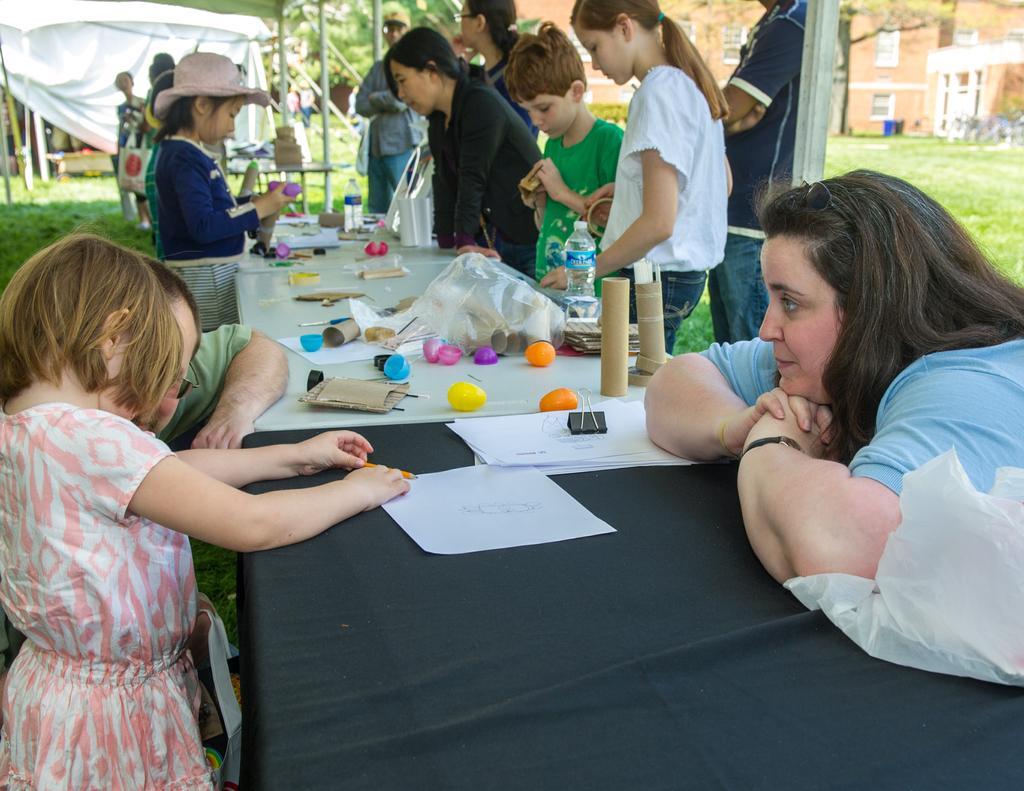Please provide a concise description of this image. Here we can see a woman on the right side looking at a pretty girl on the left side. There is a group of people who are standing in the back. In the background we can see a house on the left and right side as well. 